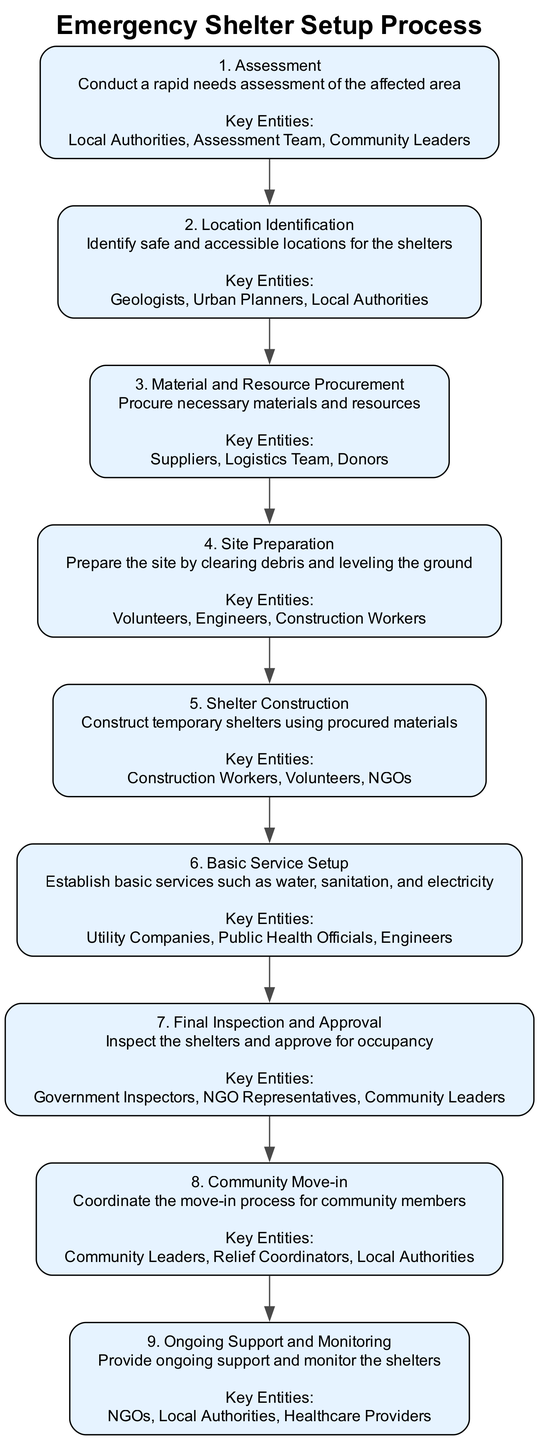What is the first step in the Emergency Shelter Setup Process? The first step is assessment, which involves conducting a rapid needs assessment of the affected area. This is identified in the diagram as the starting point labeled "1. Assessment."
Answer: Assessment How many key entities are listed for site preparation? For site preparation, three key entities are mentioned: Volunteers, Engineers, and Construction Workers. This is identified in the diagram under step 4.
Answer: 3 What action follows after material and resource procurement? The action that follows material and resource procurement is site preparation. In the diagram, this can be seen as the direct progression from step 3 to step 4.
Answer: Site Preparation Which action involves establishing water, sanitation, and electricity? The action that involves establishing basic services such as water, sanitation, and electricity is described in step 6 as "Basic Service Setup."
Answer: Basic Service Setup Who is responsible for the final inspection and approval of the shelters? The final inspection and approval of the shelters is the responsibility of Government Inspectors, NGO Representatives, and Community Leaders, as indicated in step 7 of the diagram.
Answer: Government Inspectors, NGO Representatives, Community Leaders What is the last step of the Emergency Shelter Setup Process? The last step of the process is ongoing support and monitoring, as shown in step 9 of the diagram. This follows the community move-in step.
Answer: Ongoing Support and Monitoring How many steps are there in the Emergency Shelter Setup Process? The total number of steps outlined in the diagram is 9. This can be confirmed by counting the individual actions listed in the flowchart.
Answer: 9 Which roles are key entities in shelter construction? In shelter construction, the key entities are Construction Workers, Volunteers, and NGOs, as listed under step 5 in the diagram.
Answer: Construction Workers, Volunteers, NGOs 